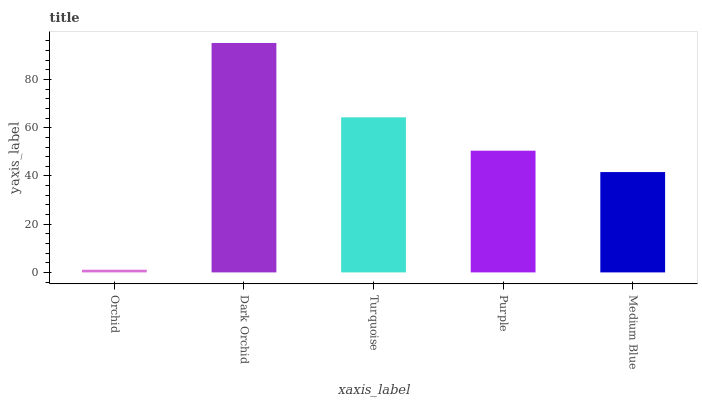Is Orchid the minimum?
Answer yes or no. Yes. Is Dark Orchid the maximum?
Answer yes or no. Yes. Is Turquoise the minimum?
Answer yes or no. No. Is Turquoise the maximum?
Answer yes or no. No. Is Dark Orchid greater than Turquoise?
Answer yes or no. Yes. Is Turquoise less than Dark Orchid?
Answer yes or no. Yes. Is Turquoise greater than Dark Orchid?
Answer yes or no. No. Is Dark Orchid less than Turquoise?
Answer yes or no. No. Is Purple the high median?
Answer yes or no. Yes. Is Purple the low median?
Answer yes or no. Yes. Is Dark Orchid the high median?
Answer yes or no. No. Is Turquoise the low median?
Answer yes or no. No. 